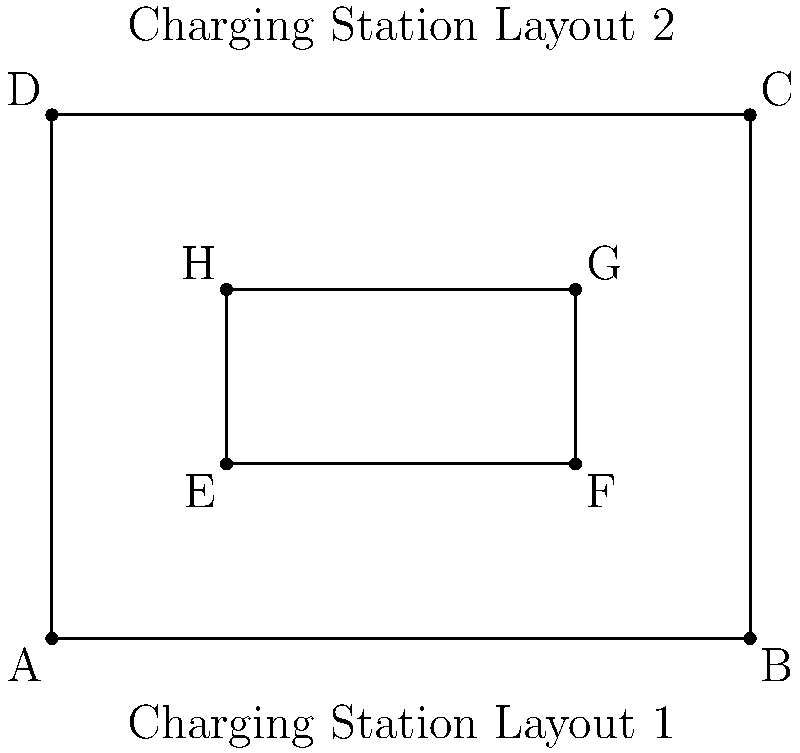Two electric vehicle charging station layouts in urban areas are shown above. If the dimensions of Layout 1 are 4 units by 3 units, and Layout 2 is similar but scaled down by a factor of $\frac{1}{2}$, prove that the two layouts are congruent to each other using the SSS (Side-Side-Side) congruence criterion. To prove that the two layouts are congruent using the SSS criterion, we need to show that all corresponding sides are proportional:

1. First, let's identify the corresponding sides:
   Layout 1: AB, BC, CD, DA
   Layout 2: EF, FG, GH, HE

2. Given information:
   - Layout 1 dimensions: 4 units by 3 units
   - Layout 2 is scaled down by a factor of $\frac{1}{2}$

3. Calculate the side lengths of Layout 1:
   AB = 4 units, BC = 3 units, CD = 4 units, DA = 3 units

4. Calculate the side lengths of Layout 2:
   EF = 4 * $\frac{1}{2}$ = 2 units
   FG = 3 * $\frac{1}{2}$ = 1.5 units
   GH = 4 * $\frac{1}{2}$ = 2 units
   HE = 3 * $\frac{1}{2}$ = 1.5 units

5. Check the proportionality of corresponding sides:
   $\frac{AB}{EF} = \frac{4}{2} = 2$
   $\frac{BC}{FG} = \frac{3}{1.5} = 2$
   $\frac{CD}{GH} = \frac{4}{2} = 2$
   $\frac{DA}{HE} = \frac{3}{1.5} = 2$

6. Since all corresponding sides are proportional with the same scale factor (2), the two layouts are similar.

7. However, for congruence, we need to show that the layouts are not only similar but also have the same size. In this case, they are not the same size due to the scaling factor of $\frac{1}{2}$.

Therefore, while the layouts are similar, they are not congruent.
Answer: Not congruent, only similar 